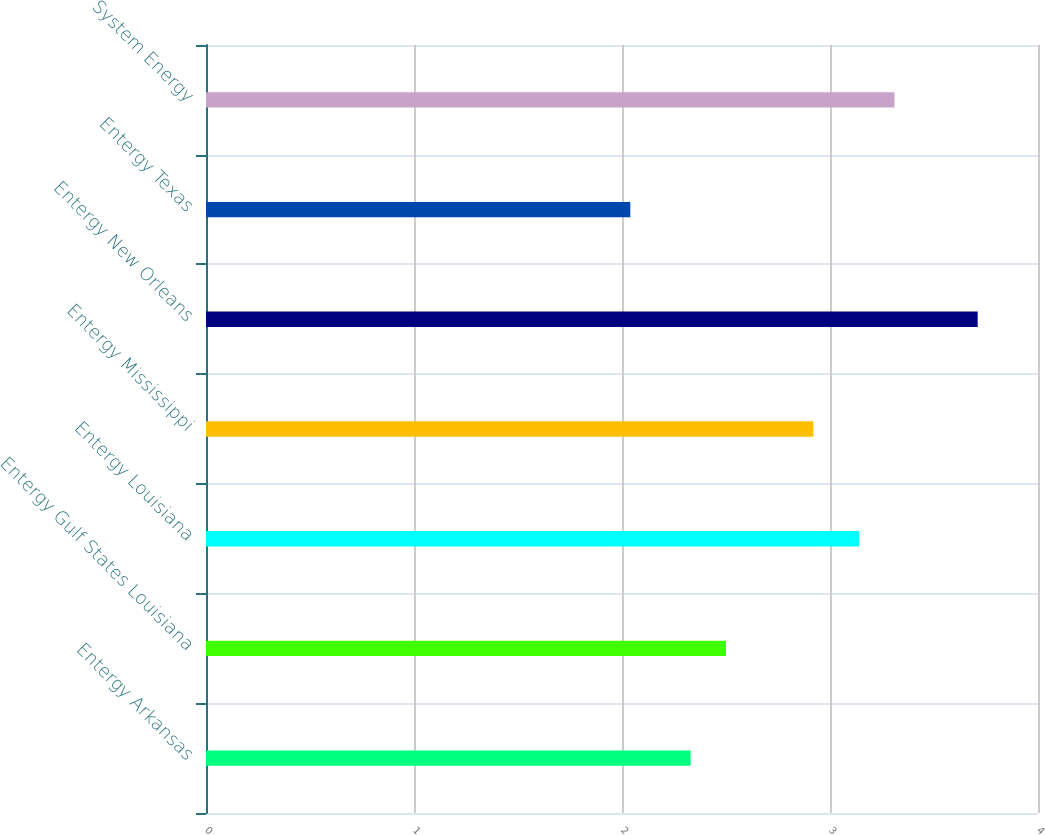Convert chart to OTSL. <chart><loc_0><loc_0><loc_500><loc_500><bar_chart><fcel>Entergy Arkansas<fcel>Entergy Gulf States Louisiana<fcel>Entergy Louisiana<fcel>Entergy Mississippi<fcel>Entergy New Orleans<fcel>Entergy Texas<fcel>System Energy<nl><fcel>2.33<fcel>2.5<fcel>3.14<fcel>2.92<fcel>3.71<fcel>2.04<fcel>3.31<nl></chart> 